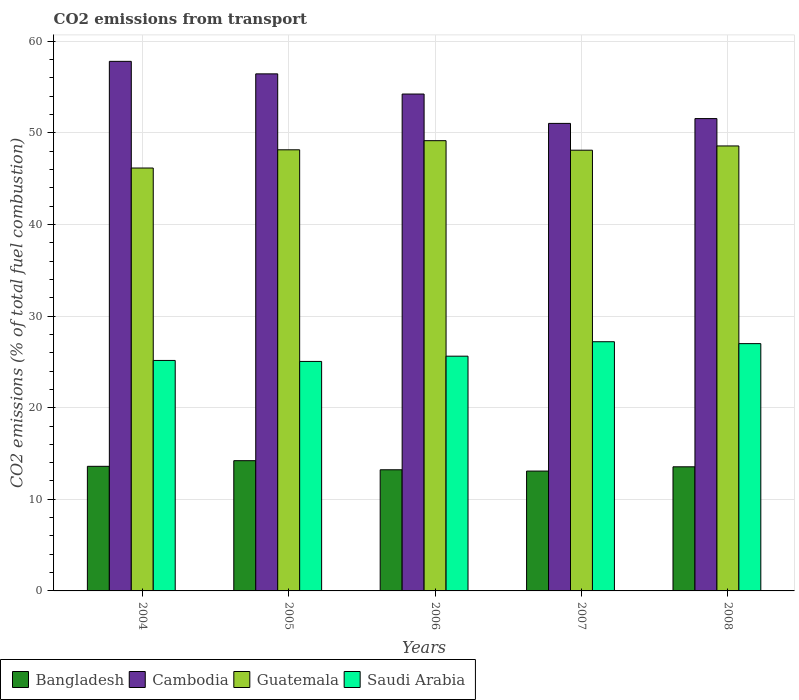How many groups of bars are there?
Provide a succinct answer. 5. Are the number of bars per tick equal to the number of legend labels?
Your answer should be compact. Yes. How many bars are there on the 1st tick from the right?
Your answer should be compact. 4. What is the total CO2 emitted in Bangladesh in 2005?
Give a very brief answer. 14.22. Across all years, what is the maximum total CO2 emitted in Saudi Arabia?
Your answer should be very brief. 27.2. Across all years, what is the minimum total CO2 emitted in Bangladesh?
Keep it short and to the point. 13.08. In which year was the total CO2 emitted in Saudi Arabia maximum?
Give a very brief answer. 2007. In which year was the total CO2 emitted in Cambodia minimum?
Offer a terse response. 2007. What is the total total CO2 emitted in Cambodia in the graph?
Offer a terse response. 271.07. What is the difference between the total CO2 emitted in Cambodia in 2005 and that in 2006?
Give a very brief answer. 2.2. What is the difference between the total CO2 emitted in Bangladesh in 2006 and the total CO2 emitted in Guatemala in 2004?
Ensure brevity in your answer.  -32.94. What is the average total CO2 emitted in Cambodia per year?
Provide a short and direct response. 54.21. In the year 2005, what is the difference between the total CO2 emitted in Bangladesh and total CO2 emitted in Saudi Arabia?
Ensure brevity in your answer.  -10.83. What is the ratio of the total CO2 emitted in Bangladesh in 2005 to that in 2006?
Your response must be concise. 1.08. Is the difference between the total CO2 emitted in Bangladesh in 2004 and 2008 greater than the difference between the total CO2 emitted in Saudi Arabia in 2004 and 2008?
Offer a terse response. Yes. What is the difference between the highest and the second highest total CO2 emitted in Bangladesh?
Your answer should be very brief. 0.61. What is the difference between the highest and the lowest total CO2 emitted in Cambodia?
Your answer should be compact. 6.77. Is the sum of the total CO2 emitted in Saudi Arabia in 2004 and 2006 greater than the maximum total CO2 emitted in Guatemala across all years?
Your answer should be compact. Yes. Is it the case that in every year, the sum of the total CO2 emitted in Saudi Arabia and total CO2 emitted in Cambodia is greater than the sum of total CO2 emitted in Bangladesh and total CO2 emitted in Guatemala?
Offer a very short reply. Yes. What does the 4th bar from the left in 2006 represents?
Your answer should be very brief. Saudi Arabia. What does the 4th bar from the right in 2004 represents?
Provide a succinct answer. Bangladesh. Are the values on the major ticks of Y-axis written in scientific E-notation?
Provide a short and direct response. No. Does the graph contain grids?
Keep it short and to the point. Yes. What is the title of the graph?
Offer a terse response. CO2 emissions from transport. What is the label or title of the X-axis?
Provide a short and direct response. Years. What is the label or title of the Y-axis?
Keep it short and to the point. CO2 emissions (% of total fuel combustion). What is the CO2 emissions (% of total fuel combustion) in Bangladesh in 2004?
Offer a very short reply. 13.6. What is the CO2 emissions (% of total fuel combustion) of Cambodia in 2004?
Provide a short and direct response. 57.81. What is the CO2 emissions (% of total fuel combustion) in Guatemala in 2004?
Offer a terse response. 46.16. What is the CO2 emissions (% of total fuel combustion) in Saudi Arabia in 2004?
Offer a very short reply. 25.16. What is the CO2 emissions (% of total fuel combustion) in Bangladesh in 2005?
Provide a succinct answer. 14.22. What is the CO2 emissions (% of total fuel combustion) of Cambodia in 2005?
Offer a terse response. 56.44. What is the CO2 emissions (% of total fuel combustion) of Guatemala in 2005?
Your answer should be compact. 48.15. What is the CO2 emissions (% of total fuel combustion) of Saudi Arabia in 2005?
Your answer should be very brief. 25.05. What is the CO2 emissions (% of total fuel combustion) of Bangladesh in 2006?
Give a very brief answer. 13.22. What is the CO2 emissions (% of total fuel combustion) of Cambodia in 2006?
Give a very brief answer. 54.24. What is the CO2 emissions (% of total fuel combustion) of Guatemala in 2006?
Provide a short and direct response. 49.15. What is the CO2 emissions (% of total fuel combustion) in Saudi Arabia in 2006?
Provide a succinct answer. 25.62. What is the CO2 emissions (% of total fuel combustion) of Bangladesh in 2007?
Offer a very short reply. 13.08. What is the CO2 emissions (% of total fuel combustion) of Cambodia in 2007?
Keep it short and to the point. 51.03. What is the CO2 emissions (% of total fuel combustion) in Guatemala in 2007?
Your response must be concise. 48.11. What is the CO2 emissions (% of total fuel combustion) in Saudi Arabia in 2007?
Your response must be concise. 27.2. What is the CO2 emissions (% of total fuel combustion) of Bangladesh in 2008?
Your answer should be very brief. 13.55. What is the CO2 emissions (% of total fuel combustion) in Cambodia in 2008?
Offer a very short reply. 51.56. What is the CO2 emissions (% of total fuel combustion) of Guatemala in 2008?
Your response must be concise. 48.57. What is the CO2 emissions (% of total fuel combustion) in Saudi Arabia in 2008?
Ensure brevity in your answer.  26.99. Across all years, what is the maximum CO2 emissions (% of total fuel combustion) in Bangladesh?
Your answer should be compact. 14.22. Across all years, what is the maximum CO2 emissions (% of total fuel combustion) of Cambodia?
Offer a very short reply. 57.81. Across all years, what is the maximum CO2 emissions (% of total fuel combustion) of Guatemala?
Provide a short and direct response. 49.15. Across all years, what is the maximum CO2 emissions (% of total fuel combustion) in Saudi Arabia?
Make the answer very short. 27.2. Across all years, what is the minimum CO2 emissions (% of total fuel combustion) in Bangladesh?
Your response must be concise. 13.08. Across all years, what is the minimum CO2 emissions (% of total fuel combustion) in Cambodia?
Give a very brief answer. 51.03. Across all years, what is the minimum CO2 emissions (% of total fuel combustion) in Guatemala?
Your response must be concise. 46.16. Across all years, what is the minimum CO2 emissions (% of total fuel combustion) in Saudi Arabia?
Offer a very short reply. 25.05. What is the total CO2 emissions (% of total fuel combustion) in Bangladesh in the graph?
Your response must be concise. 67.67. What is the total CO2 emissions (% of total fuel combustion) in Cambodia in the graph?
Provide a short and direct response. 271.07. What is the total CO2 emissions (% of total fuel combustion) of Guatemala in the graph?
Offer a terse response. 240.14. What is the total CO2 emissions (% of total fuel combustion) in Saudi Arabia in the graph?
Give a very brief answer. 130.03. What is the difference between the CO2 emissions (% of total fuel combustion) in Bangladesh in 2004 and that in 2005?
Keep it short and to the point. -0.61. What is the difference between the CO2 emissions (% of total fuel combustion) of Cambodia in 2004 and that in 2005?
Your answer should be very brief. 1.37. What is the difference between the CO2 emissions (% of total fuel combustion) of Guatemala in 2004 and that in 2005?
Provide a succinct answer. -1.99. What is the difference between the CO2 emissions (% of total fuel combustion) of Saudi Arabia in 2004 and that in 2005?
Make the answer very short. 0.11. What is the difference between the CO2 emissions (% of total fuel combustion) in Bangladesh in 2004 and that in 2006?
Ensure brevity in your answer.  0.38. What is the difference between the CO2 emissions (% of total fuel combustion) in Cambodia in 2004 and that in 2006?
Your response must be concise. 3.57. What is the difference between the CO2 emissions (% of total fuel combustion) in Guatemala in 2004 and that in 2006?
Provide a short and direct response. -2.98. What is the difference between the CO2 emissions (% of total fuel combustion) in Saudi Arabia in 2004 and that in 2006?
Make the answer very short. -0.47. What is the difference between the CO2 emissions (% of total fuel combustion) in Bangladesh in 2004 and that in 2007?
Your response must be concise. 0.52. What is the difference between the CO2 emissions (% of total fuel combustion) of Cambodia in 2004 and that in 2007?
Give a very brief answer. 6.77. What is the difference between the CO2 emissions (% of total fuel combustion) of Guatemala in 2004 and that in 2007?
Provide a succinct answer. -1.95. What is the difference between the CO2 emissions (% of total fuel combustion) in Saudi Arabia in 2004 and that in 2007?
Provide a succinct answer. -2.04. What is the difference between the CO2 emissions (% of total fuel combustion) in Bangladesh in 2004 and that in 2008?
Offer a very short reply. 0.05. What is the difference between the CO2 emissions (% of total fuel combustion) of Cambodia in 2004 and that in 2008?
Offer a very short reply. 6.25. What is the difference between the CO2 emissions (% of total fuel combustion) in Guatemala in 2004 and that in 2008?
Offer a terse response. -2.41. What is the difference between the CO2 emissions (% of total fuel combustion) of Saudi Arabia in 2004 and that in 2008?
Your answer should be compact. -1.84. What is the difference between the CO2 emissions (% of total fuel combustion) of Cambodia in 2005 and that in 2006?
Give a very brief answer. 2.2. What is the difference between the CO2 emissions (% of total fuel combustion) in Guatemala in 2005 and that in 2006?
Make the answer very short. -0.99. What is the difference between the CO2 emissions (% of total fuel combustion) in Saudi Arabia in 2005 and that in 2006?
Offer a very short reply. -0.57. What is the difference between the CO2 emissions (% of total fuel combustion) in Bangladesh in 2005 and that in 2007?
Offer a very short reply. 1.13. What is the difference between the CO2 emissions (% of total fuel combustion) of Cambodia in 2005 and that in 2007?
Offer a very short reply. 5.41. What is the difference between the CO2 emissions (% of total fuel combustion) of Guatemala in 2005 and that in 2007?
Provide a succinct answer. 0.04. What is the difference between the CO2 emissions (% of total fuel combustion) in Saudi Arabia in 2005 and that in 2007?
Keep it short and to the point. -2.15. What is the difference between the CO2 emissions (% of total fuel combustion) of Bangladesh in 2005 and that in 2008?
Provide a short and direct response. 0.67. What is the difference between the CO2 emissions (% of total fuel combustion) of Cambodia in 2005 and that in 2008?
Your answer should be compact. 4.88. What is the difference between the CO2 emissions (% of total fuel combustion) of Guatemala in 2005 and that in 2008?
Your answer should be very brief. -0.42. What is the difference between the CO2 emissions (% of total fuel combustion) in Saudi Arabia in 2005 and that in 2008?
Provide a short and direct response. -1.94. What is the difference between the CO2 emissions (% of total fuel combustion) of Bangladesh in 2006 and that in 2007?
Give a very brief answer. 0.14. What is the difference between the CO2 emissions (% of total fuel combustion) in Cambodia in 2006 and that in 2007?
Ensure brevity in your answer.  3.2. What is the difference between the CO2 emissions (% of total fuel combustion) of Guatemala in 2006 and that in 2007?
Your answer should be compact. 1.04. What is the difference between the CO2 emissions (% of total fuel combustion) in Saudi Arabia in 2006 and that in 2007?
Keep it short and to the point. -1.58. What is the difference between the CO2 emissions (% of total fuel combustion) of Bangladesh in 2006 and that in 2008?
Ensure brevity in your answer.  -0.32. What is the difference between the CO2 emissions (% of total fuel combustion) of Cambodia in 2006 and that in 2008?
Your answer should be very brief. 2.68. What is the difference between the CO2 emissions (% of total fuel combustion) of Guatemala in 2006 and that in 2008?
Offer a terse response. 0.57. What is the difference between the CO2 emissions (% of total fuel combustion) in Saudi Arabia in 2006 and that in 2008?
Your response must be concise. -1.37. What is the difference between the CO2 emissions (% of total fuel combustion) of Bangladesh in 2007 and that in 2008?
Your response must be concise. -0.47. What is the difference between the CO2 emissions (% of total fuel combustion) of Cambodia in 2007 and that in 2008?
Offer a very short reply. -0.53. What is the difference between the CO2 emissions (% of total fuel combustion) of Guatemala in 2007 and that in 2008?
Offer a very short reply. -0.46. What is the difference between the CO2 emissions (% of total fuel combustion) in Saudi Arabia in 2007 and that in 2008?
Keep it short and to the point. 0.21. What is the difference between the CO2 emissions (% of total fuel combustion) of Bangladesh in 2004 and the CO2 emissions (% of total fuel combustion) of Cambodia in 2005?
Keep it short and to the point. -42.84. What is the difference between the CO2 emissions (% of total fuel combustion) of Bangladesh in 2004 and the CO2 emissions (% of total fuel combustion) of Guatemala in 2005?
Your answer should be compact. -34.55. What is the difference between the CO2 emissions (% of total fuel combustion) of Bangladesh in 2004 and the CO2 emissions (% of total fuel combustion) of Saudi Arabia in 2005?
Your answer should be compact. -11.45. What is the difference between the CO2 emissions (% of total fuel combustion) of Cambodia in 2004 and the CO2 emissions (% of total fuel combustion) of Guatemala in 2005?
Your response must be concise. 9.65. What is the difference between the CO2 emissions (% of total fuel combustion) in Cambodia in 2004 and the CO2 emissions (% of total fuel combustion) in Saudi Arabia in 2005?
Your answer should be compact. 32.76. What is the difference between the CO2 emissions (% of total fuel combustion) in Guatemala in 2004 and the CO2 emissions (% of total fuel combustion) in Saudi Arabia in 2005?
Provide a short and direct response. 21.11. What is the difference between the CO2 emissions (% of total fuel combustion) of Bangladesh in 2004 and the CO2 emissions (% of total fuel combustion) of Cambodia in 2006?
Your answer should be very brief. -40.64. What is the difference between the CO2 emissions (% of total fuel combustion) of Bangladesh in 2004 and the CO2 emissions (% of total fuel combustion) of Guatemala in 2006?
Your response must be concise. -35.54. What is the difference between the CO2 emissions (% of total fuel combustion) of Bangladesh in 2004 and the CO2 emissions (% of total fuel combustion) of Saudi Arabia in 2006?
Offer a terse response. -12.02. What is the difference between the CO2 emissions (% of total fuel combustion) in Cambodia in 2004 and the CO2 emissions (% of total fuel combustion) in Guatemala in 2006?
Make the answer very short. 8.66. What is the difference between the CO2 emissions (% of total fuel combustion) of Cambodia in 2004 and the CO2 emissions (% of total fuel combustion) of Saudi Arabia in 2006?
Your response must be concise. 32.18. What is the difference between the CO2 emissions (% of total fuel combustion) in Guatemala in 2004 and the CO2 emissions (% of total fuel combustion) in Saudi Arabia in 2006?
Ensure brevity in your answer.  20.54. What is the difference between the CO2 emissions (% of total fuel combustion) in Bangladesh in 2004 and the CO2 emissions (% of total fuel combustion) in Cambodia in 2007?
Your answer should be compact. -37.43. What is the difference between the CO2 emissions (% of total fuel combustion) of Bangladesh in 2004 and the CO2 emissions (% of total fuel combustion) of Guatemala in 2007?
Give a very brief answer. -34.51. What is the difference between the CO2 emissions (% of total fuel combustion) in Bangladesh in 2004 and the CO2 emissions (% of total fuel combustion) in Saudi Arabia in 2007?
Your answer should be very brief. -13.6. What is the difference between the CO2 emissions (% of total fuel combustion) of Cambodia in 2004 and the CO2 emissions (% of total fuel combustion) of Guatemala in 2007?
Your answer should be compact. 9.7. What is the difference between the CO2 emissions (% of total fuel combustion) of Cambodia in 2004 and the CO2 emissions (% of total fuel combustion) of Saudi Arabia in 2007?
Offer a very short reply. 30.6. What is the difference between the CO2 emissions (% of total fuel combustion) of Guatemala in 2004 and the CO2 emissions (% of total fuel combustion) of Saudi Arabia in 2007?
Ensure brevity in your answer.  18.96. What is the difference between the CO2 emissions (% of total fuel combustion) in Bangladesh in 2004 and the CO2 emissions (% of total fuel combustion) in Cambodia in 2008?
Your response must be concise. -37.96. What is the difference between the CO2 emissions (% of total fuel combustion) in Bangladesh in 2004 and the CO2 emissions (% of total fuel combustion) in Guatemala in 2008?
Your answer should be very brief. -34.97. What is the difference between the CO2 emissions (% of total fuel combustion) of Bangladesh in 2004 and the CO2 emissions (% of total fuel combustion) of Saudi Arabia in 2008?
Provide a succinct answer. -13.39. What is the difference between the CO2 emissions (% of total fuel combustion) in Cambodia in 2004 and the CO2 emissions (% of total fuel combustion) in Guatemala in 2008?
Ensure brevity in your answer.  9.23. What is the difference between the CO2 emissions (% of total fuel combustion) of Cambodia in 2004 and the CO2 emissions (% of total fuel combustion) of Saudi Arabia in 2008?
Your answer should be very brief. 30.81. What is the difference between the CO2 emissions (% of total fuel combustion) of Guatemala in 2004 and the CO2 emissions (% of total fuel combustion) of Saudi Arabia in 2008?
Ensure brevity in your answer.  19.17. What is the difference between the CO2 emissions (% of total fuel combustion) of Bangladesh in 2005 and the CO2 emissions (% of total fuel combustion) of Cambodia in 2006?
Give a very brief answer. -40.02. What is the difference between the CO2 emissions (% of total fuel combustion) in Bangladesh in 2005 and the CO2 emissions (% of total fuel combustion) in Guatemala in 2006?
Your answer should be compact. -34.93. What is the difference between the CO2 emissions (% of total fuel combustion) in Bangladesh in 2005 and the CO2 emissions (% of total fuel combustion) in Saudi Arabia in 2006?
Your answer should be compact. -11.41. What is the difference between the CO2 emissions (% of total fuel combustion) in Cambodia in 2005 and the CO2 emissions (% of total fuel combustion) in Guatemala in 2006?
Make the answer very short. 7.29. What is the difference between the CO2 emissions (% of total fuel combustion) in Cambodia in 2005 and the CO2 emissions (% of total fuel combustion) in Saudi Arabia in 2006?
Offer a very short reply. 30.82. What is the difference between the CO2 emissions (% of total fuel combustion) in Guatemala in 2005 and the CO2 emissions (% of total fuel combustion) in Saudi Arabia in 2006?
Make the answer very short. 22.53. What is the difference between the CO2 emissions (% of total fuel combustion) in Bangladesh in 2005 and the CO2 emissions (% of total fuel combustion) in Cambodia in 2007?
Provide a succinct answer. -36.82. What is the difference between the CO2 emissions (% of total fuel combustion) of Bangladesh in 2005 and the CO2 emissions (% of total fuel combustion) of Guatemala in 2007?
Your answer should be compact. -33.89. What is the difference between the CO2 emissions (% of total fuel combustion) in Bangladesh in 2005 and the CO2 emissions (% of total fuel combustion) in Saudi Arabia in 2007?
Provide a succinct answer. -12.99. What is the difference between the CO2 emissions (% of total fuel combustion) in Cambodia in 2005 and the CO2 emissions (% of total fuel combustion) in Guatemala in 2007?
Your response must be concise. 8.33. What is the difference between the CO2 emissions (% of total fuel combustion) in Cambodia in 2005 and the CO2 emissions (% of total fuel combustion) in Saudi Arabia in 2007?
Ensure brevity in your answer.  29.24. What is the difference between the CO2 emissions (% of total fuel combustion) in Guatemala in 2005 and the CO2 emissions (% of total fuel combustion) in Saudi Arabia in 2007?
Your answer should be compact. 20.95. What is the difference between the CO2 emissions (% of total fuel combustion) of Bangladesh in 2005 and the CO2 emissions (% of total fuel combustion) of Cambodia in 2008?
Your answer should be very brief. -37.34. What is the difference between the CO2 emissions (% of total fuel combustion) of Bangladesh in 2005 and the CO2 emissions (% of total fuel combustion) of Guatemala in 2008?
Your answer should be very brief. -34.35. What is the difference between the CO2 emissions (% of total fuel combustion) in Bangladesh in 2005 and the CO2 emissions (% of total fuel combustion) in Saudi Arabia in 2008?
Give a very brief answer. -12.78. What is the difference between the CO2 emissions (% of total fuel combustion) in Cambodia in 2005 and the CO2 emissions (% of total fuel combustion) in Guatemala in 2008?
Ensure brevity in your answer.  7.87. What is the difference between the CO2 emissions (% of total fuel combustion) in Cambodia in 2005 and the CO2 emissions (% of total fuel combustion) in Saudi Arabia in 2008?
Keep it short and to the point. 29.45. What is the difference between the CO2 emissions (% of total fuel combustion) in Guatemala in 2005 and the CO2 emissions (% of total fuel combustion) in Saudi Arabia in 2008?
Offer a very short reply. 21.16. What is the difference between the CO2 emissions (% of total fuel combustion) in Bangladesh in 2006 and the CO2 emissions (% of total fuel combustion) in Cambodia in 2007?
Provide a succinct answer. -37.81. What is the difference between the CO2 emissions (% of total fuel combustion) of Bangladesh in 2006 and the CO2 emissions (% of total fuel combustion) of Guatemala in 2007?
Ensure brevity in your answer.  -34.89. What is the difference between the CO2 emissions (% of total fuel combustion) of Bangladesh in 2006 and the CO2 emissions (% of total fuel combustion) of Saudi Arabia in 2007?
Your answer should be compact. -13.98. What is the difference between the CO2 emissions (% of total fuel combustion) of Cambodia in 2006 and the CO2 emissions (% of total fuel combustion) of Guatemala in 2007?
Ensure brevity in your answer.  6.13. What is the difference between the CO2 emissions (% of total fuel combustion) of Cambodia in 2006 and the CO2 emissions (% of total fuel combustion) of Saudi Arabia in 2007?
Make the answer very short. 27.04. What is the difference between the CO2 emissions (% of total fuel combustion) in Guatemala in 2006 and the CO2 emissions (% of total fuel combustion) in Saudi Arabia in 2007?
Offer a terse response. 21.94. What is the difference between the CO2 emissions (% of total fuel combustion) in Bangladesh in 2006 and the CO2 emissions (% of total fuel combustion) in Cambodia in 2008?
Make the answer very short. -38.33. What is the difference between the CO2 emissions (% of total fuel combustion) in Bangladesh in 2006 and the CO2 emissions (% of total fuel combustion) in Guatemala in 2008?
Offer a terse response. -35.35. What is the difference between the CO2 emissions (% of total fuel combustion) in Bangladesh in 2006 and the CO2 emissions (% of total fuel combustion) in Saudi Arabia in 2008?
Your response must be concise. -13.77. What is the difference between the CO2 emissions (% of total fuel combustion) in Cambodia in 2006 and the CO2 emissions (% of total fuel combustion) in Guatemala in 2008?
Make the answer very short. 5.67. What is the difference between the CO2 emissions (% of total fuel combustion) of Cambodia in 2006 and the CO2 emissions (% of total fuel combustion) of Saudi Arabia in 2008?
Offer a terse response. 27.24. What is the difference between the CO2 emissions (% of total fuel combustion) in Guatemala in 2006 and the CO2 emissions (% of total fuel combustion) in Saudi Arabia in 2008?
Provide a short and direct response. 22.15. What is the difference between the CO2 emissions (% of total fuel combustion) of Bangladesh in 2007 and the CO2 emissions (% of total fuel combustion) of Cambodia in 2008?
Offer a very short reply. -38.48. What is the difference between the CO2 emissions (% of total fuel combustion) of Bangladesh in 2007 and the CO2 emissions (% of total fuel combustion) of Guatemala in 2008?
Your response must be concise. -35.49. What is the difference between the CO2 emissions (% of total fuel combustion) in Bangladesh in 2007 and the CO2 emissions (% of total fuel combustion) in Saudi Arabia in 2008?
Provide a short and direct response. -13.91. What is the difference between the CO2 emissions (% of total fuel combustion) in Cambodia in 2007 and the CO2 emissions (% of total fuel combustion) in Guatemala in 2008?
Provide a succinct answer. 2.46. What is the difference between the CO2 emissions (% of total fuel combustion) in Cambodia in 2007 and the CO2 emissions (% of total fuel combustion) in Saudi Arabia in 2008?
Make the answer very short. 24.04. What is the difference between the CO2 emissions (% of total fuel combustion) in Guatemala in 2007 and the CO2 emissions (% of total fuel combustion) in Saudi Arabia in 2008?
Provide a succinct answer. 21.12. What is the average CO2 emissions (% of total fuel combustion) in Bangladesh per year?
Your answer should be very brief. 13.53. What is the average CO2 emissions (% of total fuel combustion) in Cambodia per year?
Offer a terse response. 54.21. What is the average CO2 emissions (% of total fuel combustion) in Guatemala per year?
Give a very brief answer. 48.03. What is the average CO2 emissions (% of total fuel combustion) of Saudi Arabia per year?
Offer a terse response. 26.01. In the year 2004, what is the difference between the CO2 emissions (% of total fuel combustion) of Bangladesh and CO2 emissions (% of total fuel combustion) of Cambodia?
Ensure brevity in your answer.  -44.2. In the year 2004, what is the difference between the CO2 emissions (% of total fuel combustion) in Bangladesh and CO2 emissions (% of total fuel combustion) in Guatemala?
Offer a very short reply. -32.56. In the year 2004, what is the difference between the CO2 emissions (% of total fuel combustion) of Bangladesh and CO2 emissions (% of total fuel combustion) of Saudi Arabia?
Offer a terse response. -11.56. In the year 2004, what is the difference between the CO2 emissions (% of total fuel combustion) in Cambodia and CO2 emissions (% of total fuel combustion) in Guatemala?
Provide a short and direct response. 11.64. In the year 2004, what is the difference between the CO2 emissions (% of total fuel combustion) of Cambodia and CO2 emissions (% of total fuel combustion) of Saudi Arabia?
Your answer should be compact. 32.65. In the year 2004, what is the difference between the CO2 emissions (% of total fuel combustion) of Guatemala and CO2 emissions (% of total fuel combustion) of Saudi Arabia?
Keep it short and to the point. 21. In the year 2005, what is the difference between the CO2 emissions (% of total fuel combustion) in Bangladesh and CO2 emissions (% of total fuel combustion) in Cambodia?
Offer a terse response. -42.22. In the year 2005, what is the difference between the CO2 emissions (% of total fuel combustion) of Bangladesh and CO2 emissions (% of total fuel combustion) of Guatemala?
Offer a very short reply. -33.94. In the year 2005, what is the difference between the CO2 emissions (% of total fuel combustion) in Bangladesh and CO2 emissions (% of total fuel combustion) in Saudi Arabia?
Ensure brevity in your answer.  -10.83. In the year 2005, what is the difference between the CO2 emissions (% of total fuel combustion) in Cambodia and CO2 emissions (% of total fuel combustion) in Guatemala?
Provide a short and direct response. 8.29. In the year 2005, what is the difference between the CO2 emissions (% of total fuel combustion) in Cambodia and CO2 emissions (% of total fuel combustion) in Saudi Arabia?
Provide a short and direct response. 31.39. In the year 2005, what is the difference between the CO2 emissions (% of total fuel combustion) of Guatemala and CO2 emissions (% of total fuel combustion) of Saudi Arabia?
Provide a succinct answer. 23.1. In the year 2006, what is the difference between the CO2 emissions (% of total fuel combustion) in Bangladesh and CO2 emissions (% of total fuel combustion) in Cambodia?
Your answer should be very brief. -41.01. In the year 2006, what is the difference between the CO2 emissions (% of total fuel combustion) of Bangladesh and CO2 emissions (% of total fuel combustion) of Guatemala?
Give a very brief answer. -35.92. In the year 2006, what is the difference between the CO2 emissions (% of total fuel combustion) of Bangladesh and CO2 emissions (% of total fuel combustion) of Saudi Arabia?
Offer a terse response. -12.4. In the year 2006, what is the difference between the CO2 emissions (% of total fuel combustion) of Cambodia and CO2 emissions (% of total fuel combustion) of Guatemala?
Provide a succinct answer. 5.09. In the year 2006, what is the difference between the CO2 emissions (% of total fuel combustion) in Cambodia and CO2 emissions (% of total fuel combustion) in Saudi Arabia?
Offer a terse response. 28.61. In the year 2006, what is the difference between the CO2 emissions (% of total fuel combustion) of Guatemala and CO2 emissions (% of total fuel combustion) of Saudi Arabia?
Your answer should be very brief. 23.52. In the year 2007, what is the difference between the CO2 emissions (% of total fuel combustion) of Bangladesh and CO2 emissions (% of total fuel combustion) of Cambodia?
Make the answer very short. -37.95. In the year 2007, what is the difference between the CO2 emissions (% of total fuel combustion) in Bangladesh and CO2 emissions (% of total fuel combustion) in Guatemala?
Give a very brief answer. -35.03. In the year 2007, what is the difference between the CO2 emissions (% of total fuel combustion) in Bangladesh and CO2 emissions (% of total fuel combustion) in Saudi Arabia?
Your answer should be compact. -14.12. In the year 2007, what is the difference between the CO2 emissions (% of total fuel combustion) in Cambodia and CO2 emissions (% of total fuel combustion) in Guatemala?
Your answer should be compact. 2.92. In the year 2007, what is the difference between the CO2 emissions (% of total fuel combustion) in Cambodia and CO2 emissions (% of total fuel combustion) in Saudi Arabia?
Provide a succinct answer. 23.83. In the year 2007, what is the difference between the CO2 emissions (% of total fuel combustion) in Guatemala and CO2 emissions (% of total fuel combustion) in Saudi Arabia?
Your answer should be very brief. 20.91. In the year 2008, what is the difference between the CO2 emissions (% of total fuel combustion) in Bangladesh and CO2 emissions (% of total fuel combustion) in Cambodia?
Your answer should be very brief. -38.01. In the year 2008, what is the difference between the CO2 emissions (% of total fuel combustion) of Bangladesh and CO2 emissions (% of total fuel combustion) of Guatemala?
Your response must be concise. -35.02. In the year 2008, what is the difference between the CO2 emissions (% of total fuel combustion) in Bangladesh and CO2 emissions (% of total fuel combustion) in Saudi Arabia?
Provide a short and direct response. -13.45. In the year 2008, what is the difference between the CO2 emissions (% of total fuel combustion) in Cambodia and CO2 emissions (% of total fuel combustion) in Guatemala?
Keep it short and to the point. 2.99. In the year 2008, what is the difference between the CO2 emissions (% of total fuel combustion) in Cambodia and CO2 emissions (% of total fuel combustion) in Saudi Arabia?
Keep it short and to the point. 24.57. In the year 2008, what is the difference between the CO2 emissions (% of total fuel combustion) in Guatemala and CO2 emissions (% of total fuel combustion) in Saudi Arabia?
Ensure brevity in your answer.  21.58. What is the ratio of the CO2 emissions (% of total fuel combustion) in Bangladesh in 2004 to that in 2005?
Provide a short and direct response. 0.96. What is the ratio of the CO2 emissions (% of total fuel combustion) in Cambodia in 2004 to that in 2005?
Make the answer very short. 1.02. What is the ratio of the CO2 emissions (% of total fuel combustion) of Guatemala in 2004 to that in 2005?
Give a very brief answer. 0.96. What is the ratio of the CO2 emissions (% of total fuel combustion) in Bangladesh in 2004 to that in 2006?
Provide a succinct answer. 1.03. What is the ratio of the CO2 emissions (% of total fuel combustion) of Cambodia in 2004 to that in 2006?
Provide a succinct answer. 1.07. What is the ratio of the CO2 emissions (% of total fuel combustion) of Guatemala in 2004 to that in 2006?
Your answer should be compact. 0.94. What is the ratio of the CO2 emissions (% of total fuel combustion) of Saudi Arabia in 2004 to that in 2006?
Ensure brevity in your answer.  0.98. What is the ratio of the CO2 emissions (% of total fuel combustion) of Bangladesh in 2004 to that in 2007?
Your response must be concise. 1.04. What is the ratio of the CO2 emissions (% of total fuel combustion) of Cambodia in 2004 to that in 2007?
Give a very brief answer. 1.13. What is the ratio of the CO2 emissions (% of total fuel combustion) in Guatemala in 2004 to that in 2007?
Your answer should be compact. 0.96. What is the ratio of the CO2 emissions (% of total fuel combustion) of Saudi Arabia in 2004 to that in 2007?
Ensure brevity in your answer.  0.92. What is the ratio of the CO2 emissions (% of total fuel combustion) of Bangladesh in 2004 to that in 2008?
Ensure brevity in your answer.  1. What is the ratio of the CO2 emissions (% of total fuel combustion) in Cambodia in 2004 to that in 2008?
Provide a succinct answer. 1.12. What is the ratio of the CO2 emissions (% of total fuel combustion) of Guatemala in 2004 to that in 2008?
Give a very brief answer. 0.95. What is the ratio of the CO2 emissions (% of total fuel combustion) of Saudi Arabia in 2004 to that in 2008?
Ensure brevity in your answer.  0.93. What is the ratio of the CO2 emissions (% of total fuel combustion) of Bangladesh in 2005 to that in 2006?
Provide a succinct answer. 1.08. What is the ratio of the CO2 emissions (% of total fuel combustion) in Cambodia in 2005 to that in 2006?
Give a very brief answer. 1.04. What is the ratio of the CO2 emissions (% of total fuel combustion) of Guatemala in 2005 to that in 2006?
Offer a terse response. 0.98. What is the ratio of the CO2 emissions (% of total fuel combustion) of Saudi Arabia in 2005 to that in 2006?
Give a very brief answer. 0.98. What is the ratio of the CO2 emissions (% of total fuel combustion) of Bangladesh in 2005 to that in 2007?
Ensure brevity in your answer.  1.09. What is the ratio of the CO2 emissions (% of total fuel combustion) of Cambodia in 2005 to that in 2007?
Give a very brief answer. 1.11. What is the ratio of the CO2 emissions (% of total fuel combustion) of Guatemala in 2005 to that in 2007?
Make the answer very short. 1. What is the ratio of the CO2 emissions (% of total fuel combustion) of Saudi Arabia in 2005 to that in 2007?
Your answer should be compact. 0.92. What is the ratio of the CO2 emissions (% of total fuel combustion) of Bangladesh in 2005 to that in 2008?
Provide a succinct answer. 1.05. What is the ratio of the CO2 emissions (% of total fuel combustion) in Cambodia in 2005 to that in 2008?
Offer a very short reply. 1.09. What is the ratio of the CO2 emissions (% of total fuel combustion) in Guatemala in 2005 to that in 2008?
Offer a very short reply. 0.99. What is the ratio of the CO2 emissions (% of total fuel combustion) in Saudi Arabia in 2005 to that in 2008?
Keep it short and to the point. 0.93. What is the ratio of the CO2 emissions (% of total fuel combustion) in Bangladesh in 2006 to that in 2007?
Your response must be concise. 1.01. What is the ratio of the CO2 emissions (% of total fuel combustion) in Cambodia in 2006 to that in 2007?
Offer a terse response. 1.06. What is the ratio of the CO2 emissions (% of total fuel combustion) in Guatemala in 2006 to that in 2007?
Give a very brief answer. 1.02. What is the ratio of the CO2 emissions (% of total fuel combustion) of Saudi Arabia in 2006 to that in 2007?
Keep it short and to the point. 0.94. What is the ratio of the CO2 emissions (% of total fuel combustion) in Bangladesh in 2006 to that in 2008?
Keep it short and to the point. 0.98. What is the ratio of the CO2 emissions (% of total fuel combustion) of Cambodia in 2006 to that in 2008?
Provide a succinct answer. 1.05. What is the ratio of the CO2 emissions (% of total fuel combustion) of Guatemala in 2006 to that in 2008?
Your answer should be compact. 1.01. What is the ratio of the CO2 emissions (% of total fuel combustion) of Saudi Arabia in 2006 to that in 2008?
Your answer should be compact. 0.95. What is the ratio of the CO2 emissions (% of total fuel combustion) in Bangladesh in 2007 to that in 2008?
Provide a succinct answer. 0.97. What is the ratio of the CO2 emissions (% of total fuel combustion) of Guatemala in 2007 to that in 2008?
Your answer should be compact. 0.99. What is the ratio of the CO2 emissions (% of total fuel combustion) in Saudi Arabia in 2007 to that in 2008?
Your answer should be compact. 1.01. What is the difference between the highest and the second highest CO2 emissions (% of total fuel combustion) of Bangladesh?
Ensure brevity in your answer.  0.61. What is the difference between the highest and the second highest CO2 emissions (% of total fuel combustion) in Cambodia?
Provide a short and direct response. 1.37. What is the difference between the highest and the second highest CO2 emissions (% of total fuel combustion) of Guatemala?
Provide a succinct answer. 0.57. What is the difference between the highest and the second highest CO2 emissions (% of total fuel combustion) of Saudi Arabia?
Your response must be concise. 0.21. What is the difference between the highest and the lowest CO2 emissions (% of total fuel combustion) in Bangladesh?
Provide a succinct answer. 1.13. What is the difference between the highest and the lowest CO2 emissions (% of total fuel combustion) in Cambodia?
Provide a short and direct response. 6.77. What is the difference between the highest and the lowest CO2 emissions (% of total fuel combustion) of Guatemala?
Keep it short and to the point. 2.98. What is the difference between the highest and the lowest CO2 emissions (% of total fuel combustion) in Saudi Arabia?
Give a very brief answer. 2.15. 